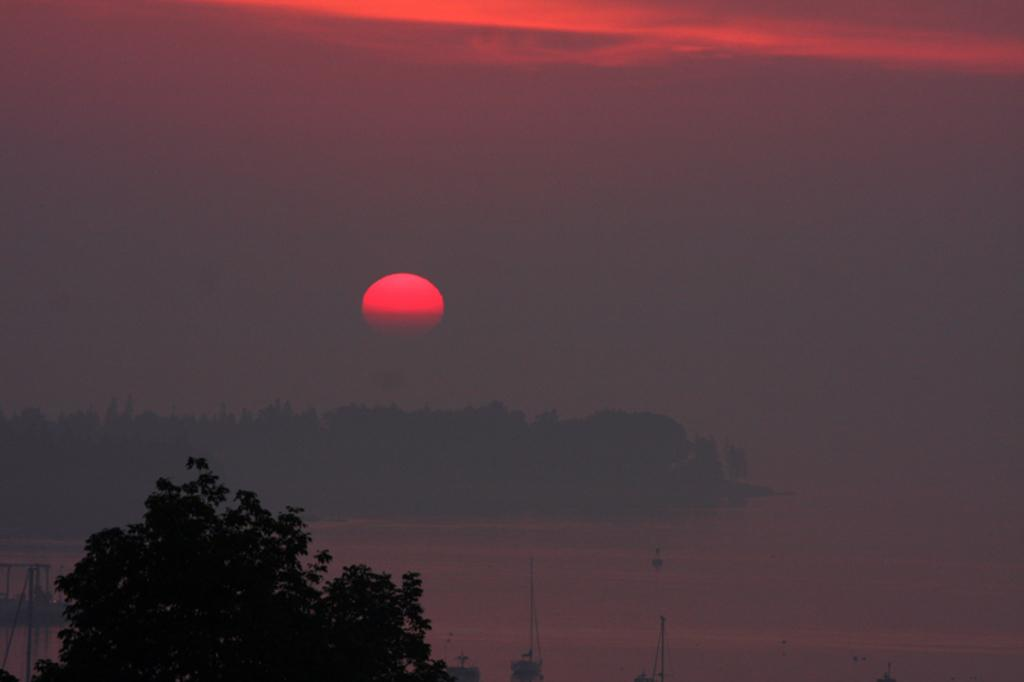What is located at the front of the image? There is a tree in the front of the image. What can be seen in the center of the image? There is water in the center of the image. What is visible in the background of the image? There are trees in the background of the image. How would you describe the sky in the image? The sky is cloudy, but the sun is visible in the sky. How many quinces are hanging from the tree in the image? There are no quinces present in the image; it only features a tree. What type of hole can be seen in the water in the image? There is no hole visible in the water in the image. 